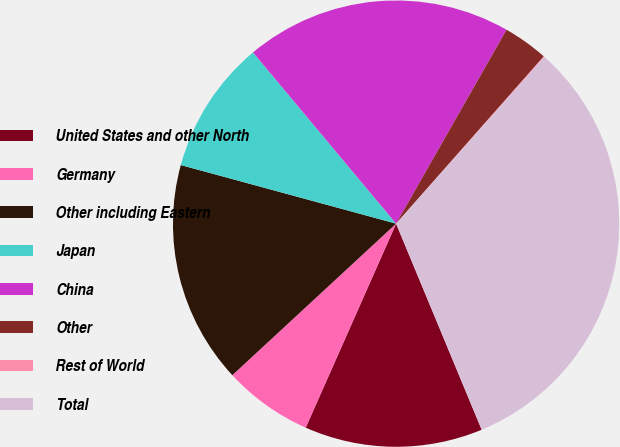Convert chart to OTSL. <chart><loc_0><loc_0><loc_500><loc_500><pie_chart><fcel>United States and other North<fcel>Germany<fcel>Other including Eastern<fcel>Japan<fcel>China<fcel>Other<fcel>Rest of World<fcel>Total<nl><fcel>12.9%<fcel>6.48%<fcel>16.11%<fcel>9.69%<fcel>19.32%<fcel>3.27%<fcel>0.06%<fcel>32.16%<nl></chart> 